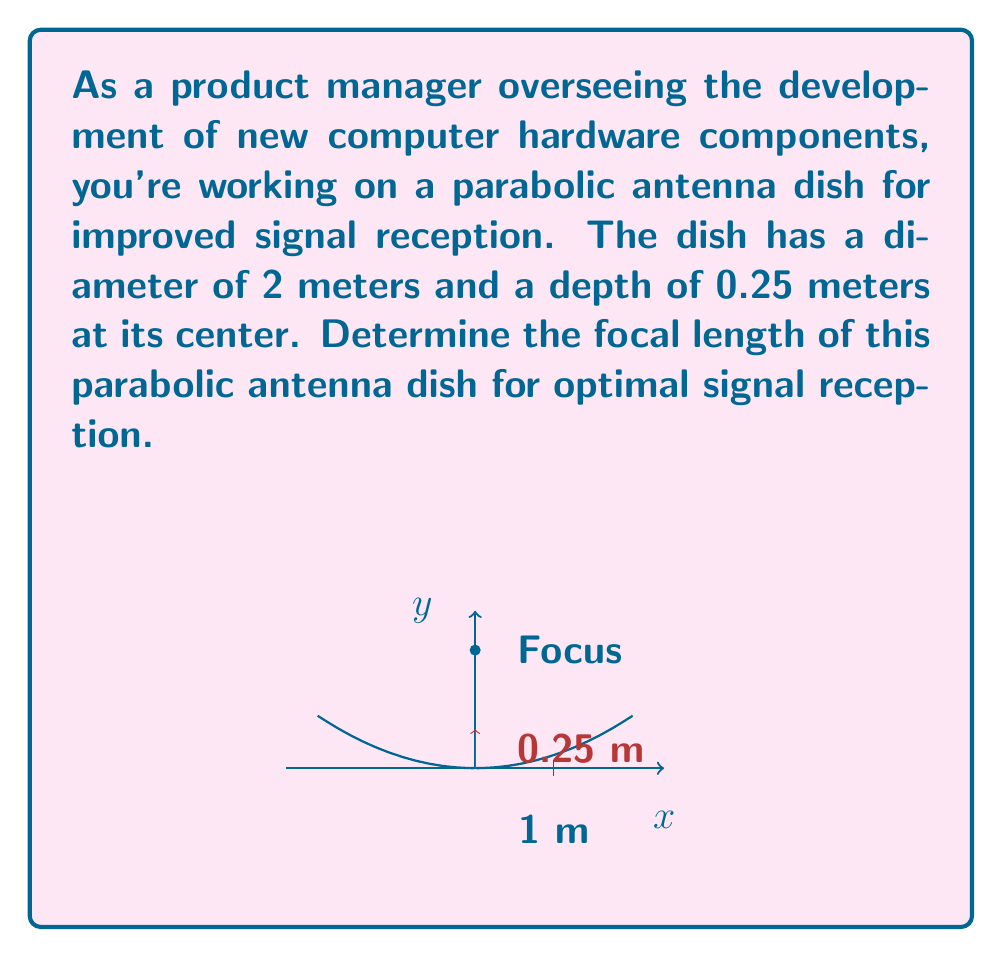Can you answer this question? Let's approach this step-by-step:

1) The general equation of a parabola with vertex at the origin and axis of symmetry along the y-axis is:

   $$y = \frac{1}{4p}x^2$$

   where $p$ is the focal length.

2) We know that the diameter of the dish is 2 meters, so the radius is 1 meter. At $x = 1$, $y = 0.25$ (the depth of the dish).

3) Substituting these values into the equation:

   $$0.25 = \frac{1}{4p}(1)^2$$

4) Simplifying:

   $$0.25 = \frac{1}{4p}$$

5) Multiplying both sides by $4p$:

   $$1 = p$$

6) Therefore, the focal length $p$ is 1 meter.

7) We can verify this result using the formula for the focal length of a parabolic dish:

   $$p = \frac{D^2}{16d}$$

   where $D$ is the diameter and $d$ is the depth.

8) Substituting our values:

   $$p = \frac{2^2}{16(0.25)} = \frac{4}{4} = 1$$

This confirms our result.
Answer: $1$ meter 